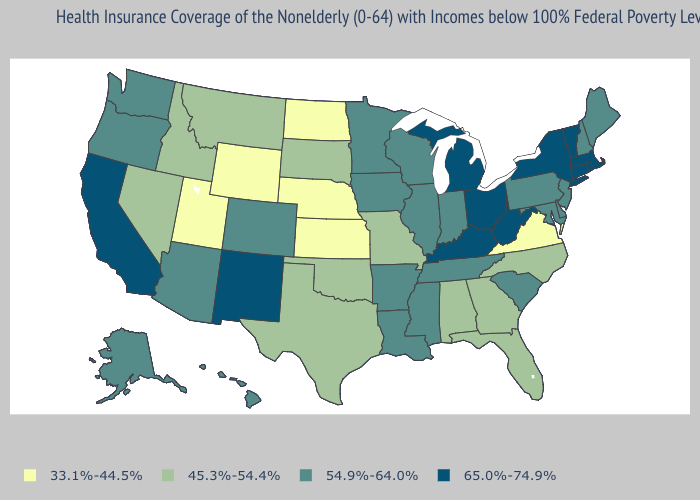What is the value of Kansas?
Quick response, please. 33.1%-44.5%. Does New Mexico have a lower value than Alaska?
Quick response, please. No. What is the value of California?
Be succinct. 65.0%-74.9%. What is the value of North Carolina?
Give a very brief answer. 45.3%-54.4%. What is the value of North Carolina?
Answer briefly. 45.3%-54.4%. Is the legend a continuous bar?
Concise answer only. No. Does West Virginia have the highest value in the South?
Give a very brief answer. Yes. Name the states that have a value in the range 45.3%-54.4%?
Concise answer only. Alabama, Florida, Georgia, Idaho, Missouri, Montana, Nevada, North Carolina, Oklahoma, South Dakota, Texas. What is the value of Oregon?
Answer briefly. 54.9%-64.0%. What is the value of Texas?
Quick response, please. 45.3%-54.4%. Which states have the highest value in the USA?
Short answer required. California, Connecticut, Kentucky, Massachusetts, Michigan, New Mexico, New York, Ohio, Rhode Island, Vermont, West Virginia. What is the lowest value in states that border Idaho?
Answer briefly. 33.1%-44.5%. What is the value of Massachusetts?
Answer briefly. 65.0%-74.9%. Does New Mexico have the lowest value in the USA?
Quick response, please. No. What is the value of Arizona?
Be succinct. 54.9%-64.0%. 